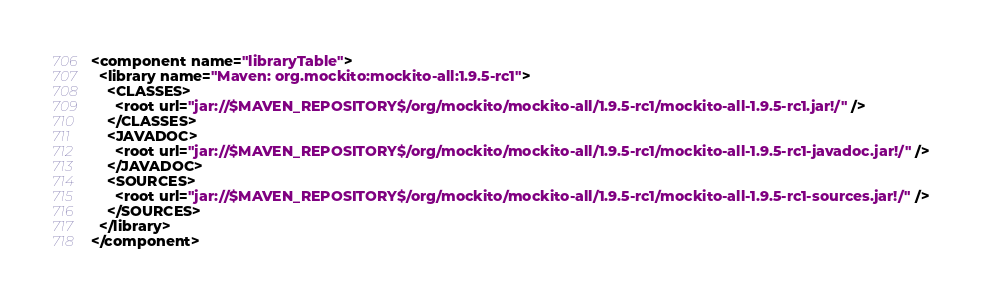Convert code to text. <code><loc_0><loc_0><loc_500><loc_500><_XML_><component name="libraryTable">
  <library name="Maven: org.mockito:mockito-all:1.9.5-rc1">
    <CLASSES>
      <root url="jar://$MAVEN_REPOSITORY$/org/mockito/mockito-all/1.9.5-rc1/mockito-all-1.9.5-rc1.jar!/" />
    </CLASSES>
    <JAVADOC>
      <root url="jar://$MAVEN_REPOSITORY$/org/mockito/mockito-all/1.9.5-rc1/mockito-all-1.9.5-rc1-javadoc.jar!/" />
    </JAVADOC>
    <SOURCES>
      <root url="jar://$MAVEN_REPOSITORY$/org/mockito/mockito-all/1.9.5-rc1/mockito-all-1.9.5-rc1-sources.jar!/" />
    </SOURCES>
  </library>
</component></code> 